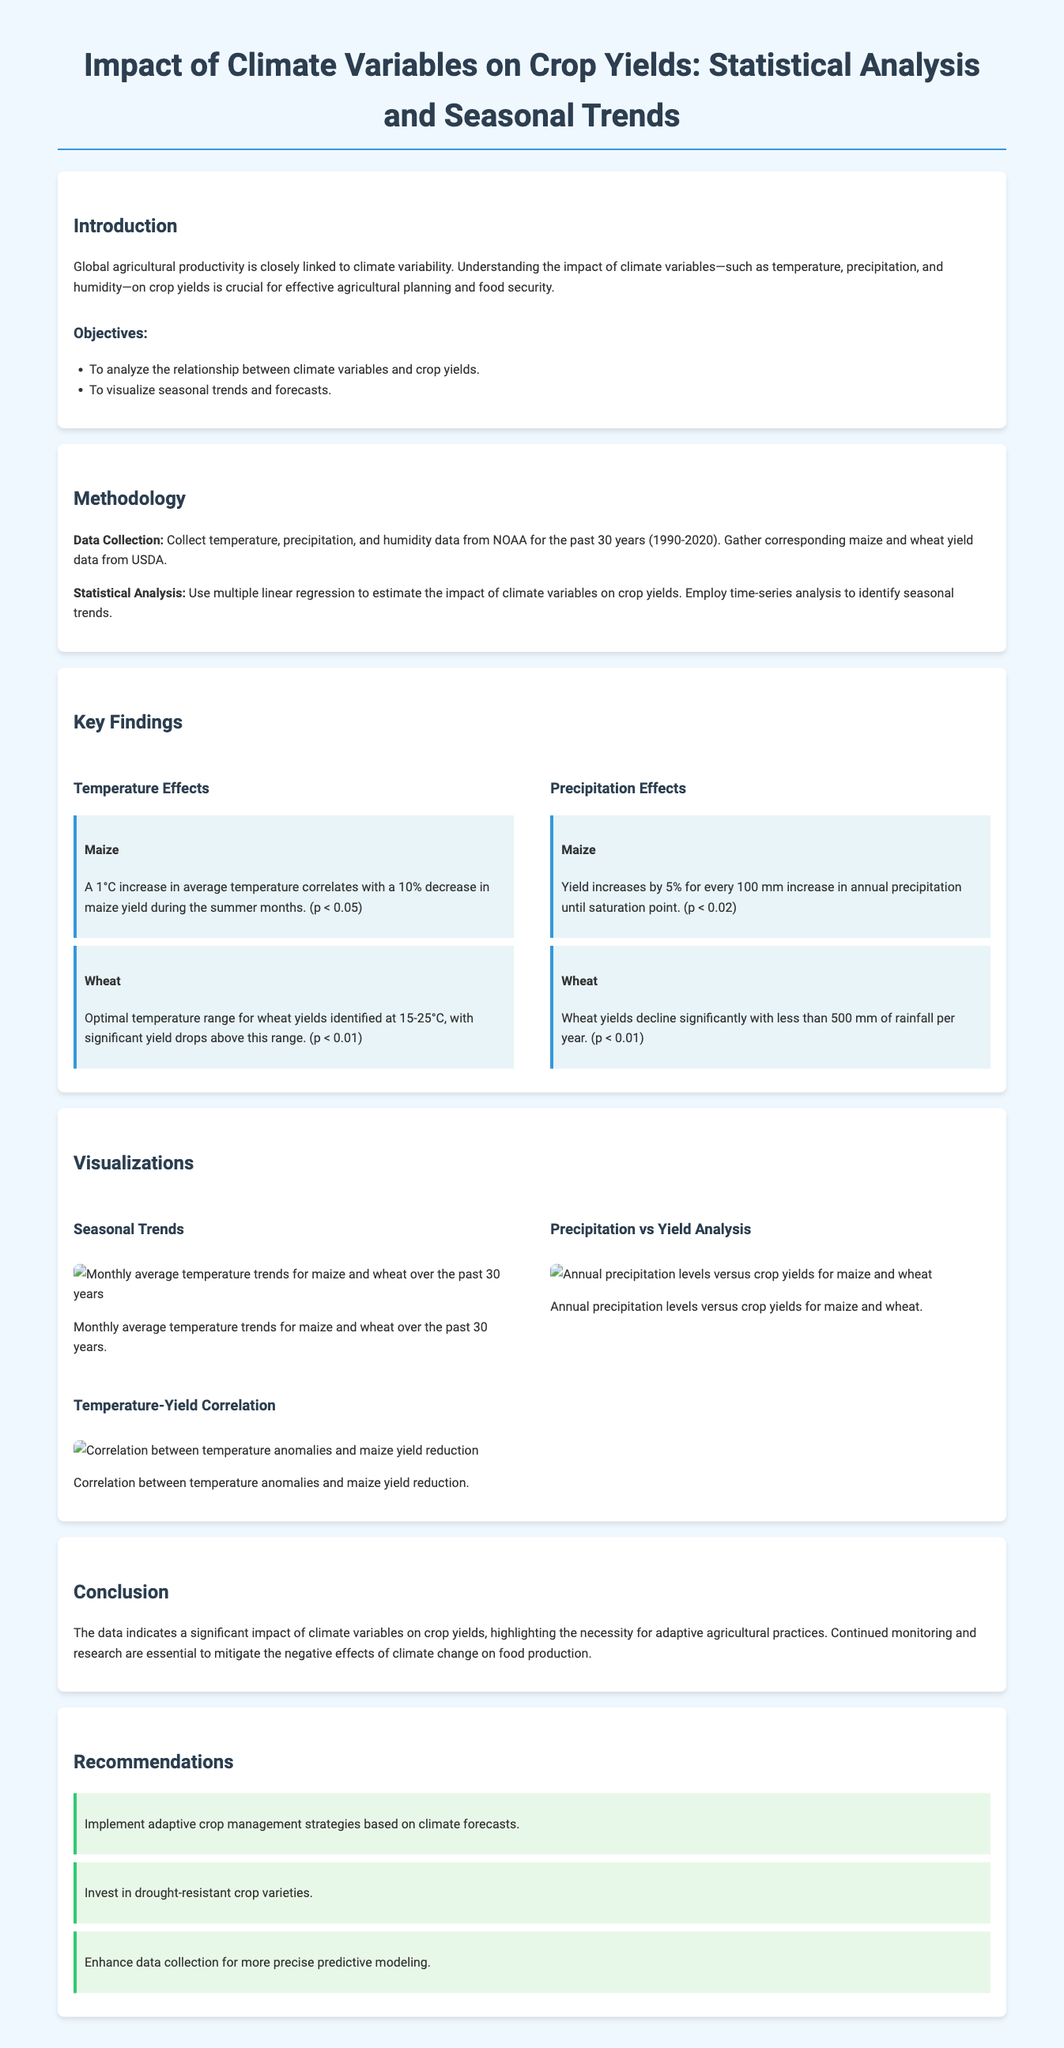What are the three climate variables mentioned? The document lists temperature, precipitation, and humidity as key climate variables affecting crop yields.
Answer: temperature, precipitation, humidity What is the correlation between temperature and maize yield reduction? The document states that a 1°C increase in average temperature correlates with a 10% decrease in maize yield during the summer months.
Answer: 10% What is the optimal temperature range for wheat yields? According to the key findings in the document, the optimal temperature range for wheat yields is identified at 15-25°C.
Answer: 15-25°C What year span does the data collection cover? The document mentions that data was collected from NOAA for 30 years, specifically from 1990 to 2020.
Answer: 1990-2020 How much does maize yield increase with precipitation? The document states that maize yield increases by 5% for every 100 mm increase in annual precipitation until the saturation point.
Answer: 5% What is one recommendation given in the report? The document provides recommendations including implementing adaptive crop management strategies based on climate forecasts.
Answer: Implement adaptive crop management strategies What was the main objective of the report? The document outlines that one of the main objectives is to analyze the relationship between climate variables and crop yields.
Answer: Analyze relationship between climate variables and crop yields What significant finding is reported for wheat yields concerning rainfall? The document states that wheat yields decline significantly with less than 500 mm of rainfall per year.
Answer: Less than 500 mm of rainfall What is highlighted as necessary for food production in the conclusion? The document emphasizes the necessity for continued monitoring and research to mitigate the negative effects of climate change on food production.
Answer: Continued monitoring and research 